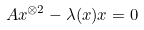<formula> <loc_0><loc_0><loc_500><loc_500>A x ^ { \otimes 2 } - \lambda ( x ) x = 0</formula> 